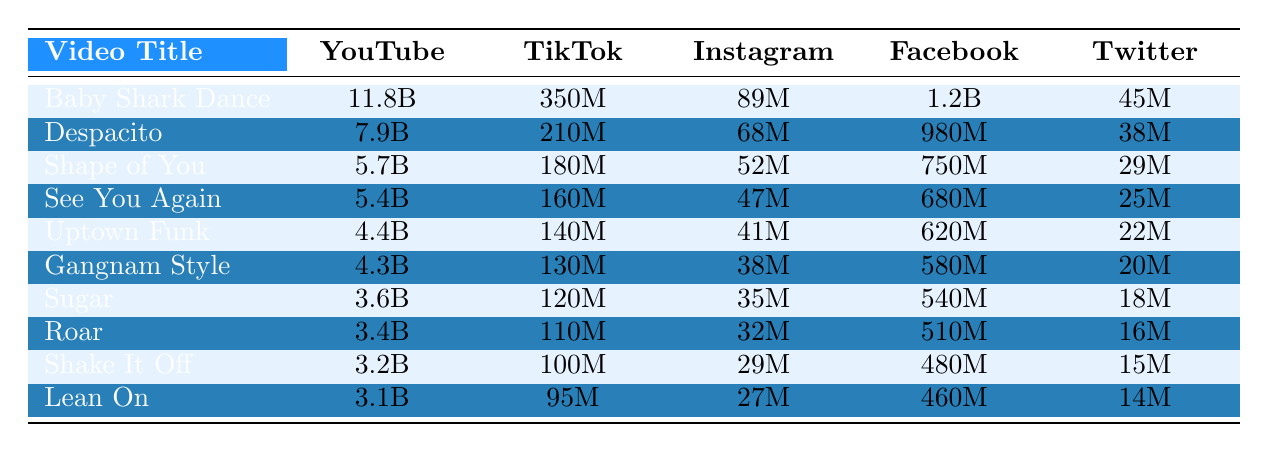What is the total view count of "Baby Shark Dance" across all platforms? The view counts for "Baby Shark Dance" are 11.8B (YouTube), 350M (TikTok), 89M (Instagram), 1.2B (Facebook), and 45M (Twitter). Converting all numbers to the same unit (millions), the totals are: 11800M + 350M + 89M + 1200M + 45M = 13484M.
Answer: 13484M Which platform has the highest view count for "Despacito"? The view counts for "Despacito" are 7.9B (YouTube), 210M (TikTok), 68M (Instagram), 980M (Facebook), and 38M (Twitter). The highest view count is 7.9B, which is on YouTube.
Answer: YouTube What is the difference in view counts between "Shape of You" on YouTube and TikTok? The views for "Shape of You" are 5.7B on YouTube and 180M on TikTok. Converting both to the same unit (millions), we have: 5700M (YouTube) - 180M (TikTok) = 5520M.
Answer: 5520M Is "Shake It Off" more popular on Instagram than "Lean On"? The view counts are 29M for "Shake It Off" on Instagram and 27M for "Lean On" on Instagram. Since 29M > 27M, "Shake It Off" is more popular on Instagram.
Answer: Yes What are the average views for the video "Uptown Funk" across all platforms? The view counts for "Uptown Funk" are 4.4B (YouTube), 140M (TikTok), 41M (Instagram), 620M (Facebook), and 22M (Twitter). Converting to millions gives us: 4400M + 140M + 41M + 620M + 22M = 5223M. There are 5 platforms, so the average is 5223M / 5 = 1044.6M.
Answer: 1044.6M What is the total view count across all platforms for "Gangnam Style"? The view counts for "Gangnam Style" are 4.3B (YouTube), 130M (TikTok), 38M (Instagram), 580M (Facebook), and 20M (Twitter). Converting to millions: 4300M + 130M + 38M + 580M + 20M = 5068M.
Answer: 5068M Which video has the lowest total views across all platforms? We calculate the total views for all videos: "Lean On" has the lowest at 3.1B (YouTube), 95M (TikTok), 27M (Instagram), 460M (Facebook), and 14M (Twitter), giving a total of 3100M + 95M + 27M + 460M + 14M = 3696M. Compared to others, "Lean On" is the lowest.
Answer: Lean On Are the views of "Sugar" on Facebook greater than those of "Roar" on TikTok? "Sugar" has 540M on Facebook and "Roar" has 110M on TikTok. Since 540M > 110M, the views of "Sugar" on Facebook are greater.
Answer: Yes What is the rank of "See You Again" by view count on YouTube? The total view counts for YouTube are: "Baby Shark Dance" (11.8B), "Despacito" (7.9B), "Shape of You" (5.7B), "See You Again" (5.4B), and so on. Thus, "See You Again" ranks 4th on YouTube.
Answer: 4th How many videos have more than 3 billion views on YouTube? The videos with more than 3 billion views on YouTube are: "Baby Shark Dance", "Despacito", "Shape of You", "See You Again", "Uptown Funk", "Gangnam Style", "Sugar", "Roar", "Shake It Off", and "Lean On". Counting these gives us 10 videos.
Answer: 10 